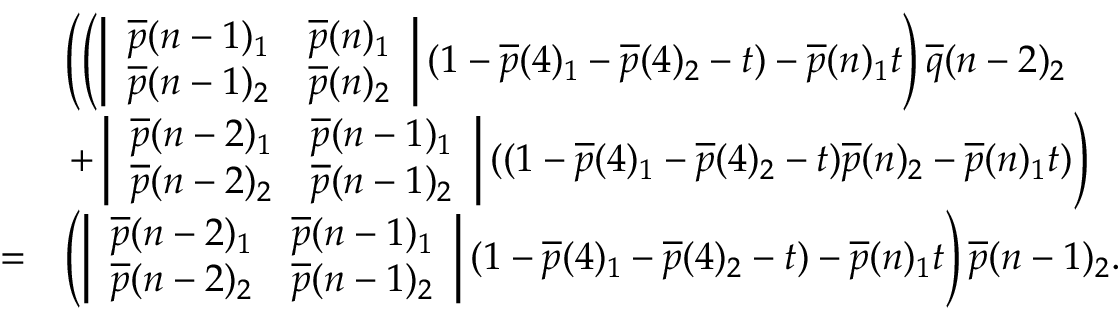<formula> <loc_0><loc_0><loc_500><loc_500>\begin{array} { r l } & { \left ( \left ( \left | \begin{array} { l l } { \overline { p } ( n - 1 ) _ { 1 } } & { \overline { p } ( n ) _ { 1 } } \\ { \overline { p } ( n - 1 ) _ { 2 } } & { \overline { p } ( n ) _ { 2 } } \end{array} \right | ( 1 - \overline { p } ( 4 ) _ { 1 } - \overline { p } ( 4 ) _ { 2 } - t ) - \overline { p } ( n ) _ { 1 } t \right ) \overline { q } ( n - 2 ) _ { 2 } } \\ & { + \left | \begin{array} { l l } { \overline { p } ( n - 2 ) _ { 1 } } & { \overline { p } ( n - 1 ) _ { 1 } } \\ { \overline { p } ( n - 2 ) _ { 2 } } & { \overline { p } ( n - 1 ) _ { 2 } } \end{array} \right | ( ( 1 - \overline { p } ( 4 ) _ { 1 } - \overline { p } ( 4 ) _ { 2 } - t ) \overline { p } ( n ) _ { 2 } - \overline { p } ( n ) _ { 1 } t ) \right ) } \\ { = } & { \left ( \left | \begin{array} { l l } { \overline { p } ( n - 2 ) _ { 1 } } & { \overline { p } ( n - 1 ) _ { 1 } } \\ { \overline { p } ( n - 2 ) _ { 2 } } & { \overline { p } ( n - 1 ) _ { 2 } } \end{array} \right | ( 1 - \overline { p } ( 4 ) _ { 1 } - \overline { p } ( 4 ) _ { 2 } - t ) - \overline { p } ( n ) _ { 1 } t \right ) \overline { p } ( n - 1 ) _ { 2 } . } \end{array}</formula> 